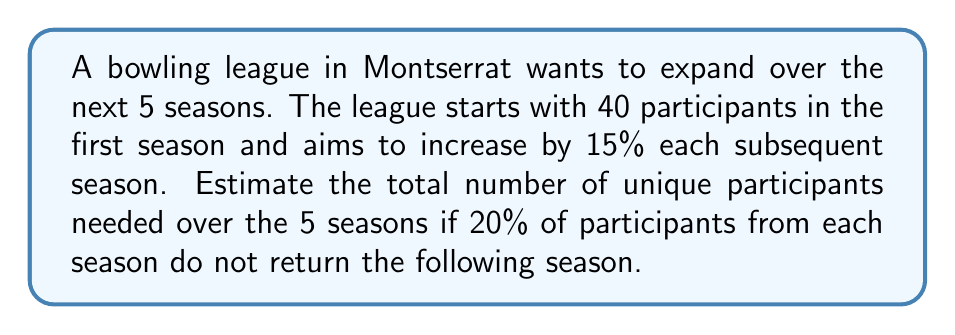Could you help me with this problem? Let's approach this step-by-step:

1) First, let's calculate the number of participants for each season:
   Season 1: 40 participants
   Season 2: $40 \times 1.15 = 46$ participants
   Season 3: $46 \times 1.15 = 52.9 \approx 53$ participants
   Season 4: $53 \times 1.15 = 60.95 \approx 61$ participants
   Season 5: $61 \times 1.15 = 70.15 \approx 70$ participants

2) Now, let's calculate the number of new participants each season:
   Season 1: 40 (all new)
   Season 2: $46 - (40 \times 0.8) = 14$ new participants
   Season 3: $53 - (46 \times 0.8) = 16$ new participants
   Season 4: $61 - (53 \times 0.8) = 19$ new participants
   Season 5: $70 - (61 \times 0.8) = 21$ new participants

3) The total number of unique participants is the sum of these new participants:
   $$ \text{Total} = 40 + 14 + 16 + 19 + 21 = 110 $$

Therefore, the estimated total number of unique participants needed over the 5 seasons is 110.
Answer: 110 participants 